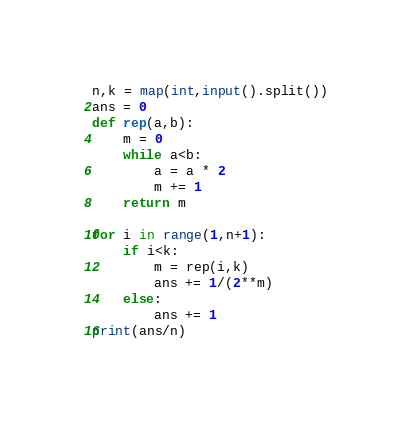<code> <loc_0><loc_0><loc_500><loc_500><_Python_>n,k = map(int,input().split())
ans = 0
def rep(a,b):
    m = 0
    while a<b:
        a = a * 2
        m += 1
    return m

for i in range(1,n+1):
    if i<k:
        m = rep(i,k)
        ans += 1/(2**m)
    else:
        ans += 1
print(ans/n)</code> 